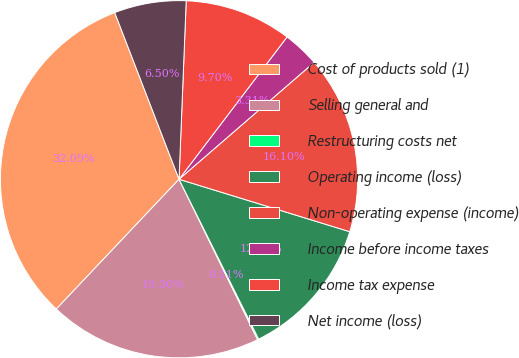Convert chart. <chart><loc_0><loc_0><loc_500><loc_500><pie_chart><fcel>Cost of products sold (1)<fcel>Selling general and<fcel>Restructuring costs net<fcel>Operating income (loss)<fcel>Non-operating expense (income)<fcel>Income before income taxes<fcel>Income tax expense<fcel>Net income (loss)<nl><fcel>32.09%<fcel>19.3%<fcel>0.11%<fcel>12.9%<fcel>16.1%<fcel>3.31%<fcel>9.7%<fcel>6.5%<nl></chart> 